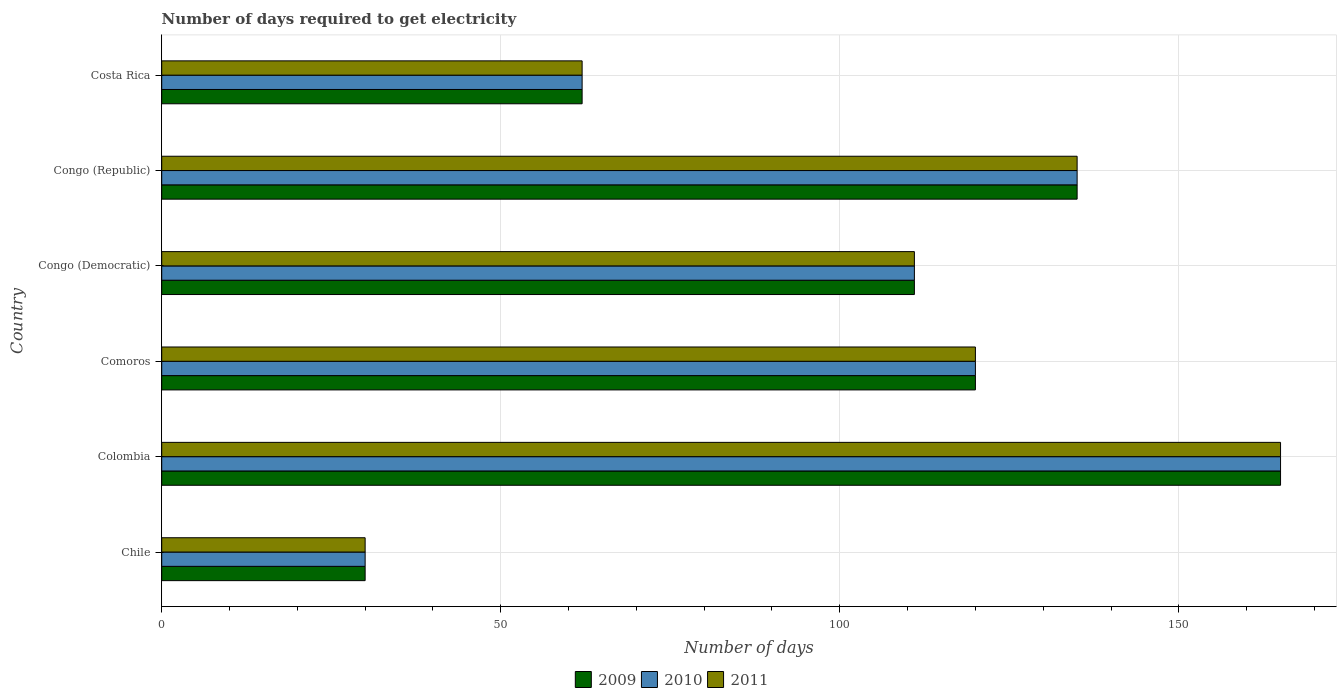How many different coloured bars are there?
Ensure brevity in your answer.  3. Are the number of bars on each tick of the Y-axis equal?
Your answer should be compact. Yes. How many bars are there on the 5th tick from the bottom?
Provide a short and direct response. 3. In how many cases, is the number of bars for a given country not equal to the number of legend labels?
Your answer should be compact. 0. What is the number of days required to get electricity in in 2011 in Costa Rica?
Offer a very short reply. 62. Across all countries, what is the maximum number of days required to get electricity in in 2010?
Your answer should be very brief. 165. In which country was the number of days required to get electricity in in 2010 maximum?
Offer a very short reply. Colombia. What is the total number of days required to get electricity in in 2009 in the graph?
Keep it short and to the point. 623. What is the difference between the number of days required to get electricity in in 2009 in Costa Rica and the number of days required to get electricity in in 2011 in Colombia?
Your answer should be compact. -103. What is the average number of days required to get electricity in in 2009 per country?
Ensure brevity in your answer.  103.83. What is the difference between the number of days required to get electricity in in 2011 and number of days required to get electricity in in 2010 in Colombia?
Your response must be concise. 0. What is the ratio of the number of days required to get electricity in in 2011 in Chile to that in Colombia?
Offer a very short reply. 0.18. Is the number of days required to get electricity in in 2011 in Comoros less than that in Congo (Democratic)?
Your answer should be very brief. No. What is the difference between the highest and the second highest number of days required to get electricity in in 2009?
Your answer should be very brief. 30. What is the difference between the highest and the lowest number of days required to get electricity in in 2009?
Your answer should be very brief. 135. What does the 3rd bar from the top in Colombia represents?
Keep it short and to the point. 2009. What does the 2nd bar from the bottom in Comoros represents?
Offer a very short reply. 2010. Is it the case that in every country, the sum of the number of days required to get electricity in in 2010 and number of days required to get electricity in in 2009 is greater than the number of days required to get electricity in in 2011?
Your response must be concise. Yes. What is the difference between two consecutive major ticks on the X-axis?
Provide a short and direct response. 50. Are the values on the major ticks of X-axis written in scientific E-notation?
Your response must be concise. No. What is the title of the graph?
Ensure brevity in your answer.  Number of days required to get electricity. Does "1995" appear as one of the legend labels in the graph?
Give a very brief answer. No. What is the label or title of the X-axis?
Give a very brief answer. Number of days. What is the Number of days in 2009 in Colombia?
Offer a terse response. 165. What is the Number of days of 2010 in Colombia?
Ensure brevity in your answer.  165. What is the Number of days in 2011 in Colombia?
Your response must be concise. 165. What is the Number of days in 2009 in Comoros?
Ensure brevity in your answer.  120. What is the Number of days of 2010 in Comoros?
Ensure brevity in your answer.  120. What is the Number of days in 2011 in Comoros?
Ensure brevity in your answer.  120. What is the Number of days in 2009 in Congo (Democratic)?
Offer a very short reply. 111. What is the Number of days of 2010 in Congo (Democratic)?
Offer a very short reply. 111. What is the Number of days in 2011 in Congo (Democratic)?
Your answer should be compact. 111. What is the Number of days of 2009 in Congo (Republic)?
Give a very brief answer. 135. What is the Number of days of 2010 in Congo (Republic)?
Your response must be concise. 135. What is the Number of days of 2011 in Congo (Republic)?
Make the answer very short. 135. What is the Number of days in 2010 in Costa Rica?
Provide a succinct answer. 62. Across all countries, what is the maximum Number of days of 2009?
Provide a short and direct response. 165. Across all countries, what is the maximum Number of days of 2010?
Ensure brevity in your answer.  165. Across all countries, what is the maximum Number of days in 2011?
Keep it short and to the point. 165. Across all countries, what is the minimum Number of days of 2009?
Give a very brief answer. 30. Across all countries, what is the minimum Number of days in 2011?
Offer a terse response. 30. What is the total Number of days in 2009 in the graph?
Provide a short and direct response. 623. What is the total Number of days in 2010 in the graph?
Make the answer very short. 623. What is the total Number of days in 2011 in the graph?
Provide a short and direct response. 623. What is the difference between the Number of days in 2009 in Chile and that in Colombia?
Ensure brevity in your answer.  -135. What is the difference between the Number of days of 2010 in Chile and that in Colombia?
Give a very brief answer. -135. What is the difference between the Number of days in 2011 in Chile and that in Colombia?
Offer a very short reply. -135. What is the difference between the Number of days of 2009 in Chile and that in Comoros?
Your response must be concise. -90. What is the difference between the Number of days in 2010 in Chile and that in Comoros?
Give a very brief answer. -90. What is the difference between the Number of days in 2011 in Chile and that in Comoros?
Make the answer very short. -90. What is the difference between the Number of days of 2009 in Chile and that in Congo (Democratic)?
Give a very brief answer. -81. What is the difference between the Number of days of 2010 in Chile and that in Congo (Democratic)?
Provide a succinct answer. -81. What is the difference between the Number of days in 2011 in Chile and that in Congo (Democratic)?
Your answer should be very brief. -81. What is the difference between the Number of days of 2009 in Chile and that in Congo (Republic)?
Provide a short and direct response. -105. What is the difference between the Number of days of 2010 in Chile and that in Congo (Republic)?
Provide a succinct answer. -105. What is the difference between the Number of days of 2011 in Chile and that in Congo (Republic)?
Your answer should be very brief. -105. What is the difference between the Number of days of 2009 in Chile and that in Costa Rica?
Your answer should be very brief. -32. What is the difference between the Number of days in 2010 in Chile and that in Costa Rica?
Provide a succinct answer. -32. What is the difference between the Number of days in 2011 in Chile and that in Costa Rica?
Provide a succinct answer. -32. What is the difference between the Number of days in 2009 in Colombia and that in Comoros?
Offer a terse response. 45. What is the difference between the Number of days in 2009 in Colombia and that in Congo (Democratic)?
Your response must be concise. 54. What is the difference between the Number of days in 2010 in Colombia and that in Congo (Republic)?
Offer a terse response. 30. What is the difference between the Number of days of 2009 in Colombia and that in Costa Rica?
Provide a short and direct response. 103. What is the difference between the Number of days of 2010 in Colombia and that in Costa Rica?
Offer a terse response. 103. What is the difference between the Number of days of 2011 in Colombia and that in Costa Rica?
Offer a terse response. 103. What is the difference between the Number of days of 2009 in Comoros and that in Congo (Democratic)?
Your response must be concise. 9. What is the difference between the Number of days in 2009 in Comoros and that in Congo (Republic)?
Your response must be concise. -15. What is the difference between the Number of days in 2010 in Congo (Democratic) and that in Congo (Republic)?
Provide a succinct answer. -24. What is the difference between the Number of days in 2011 in Congo (Democratic) and that in Congo (Republic)?
Offer a terse response. -24. What is the difference between the Number of days of 2010 in Congo (Democratic) and that in Costa Rica?
Give a very brief answer. 49. What is the difference between the Number of days in 2009 in Congo (Republic) and that in Costa Rica?
Provide a succinct answer. 73. What is the difference between the Number of days of 2009 in Chile and the Number of days of 2010 in Colombia?
Your answer should be very brief. -135. What is the difference between the Number of days of 2009 in Chile and the Number of days of 2011 in Colombia?
Your response must be concise. -135. What is the difference between the Number of days in 2010 in Chile and the Number of days in 2011 in Colombia?
Your response must be concise. -135. What is the difference between the Number of days in 2009 in Chile and the Number of days in 2010 in Comoros?
Your answer should be compact. -90. What is the difference between the Number of days in 2009 in Chile and the Number of days in 2011 in Comoros?
Your answer should be compact. -90. What is the difference between the Number of days in 2010 in Chile and the Number of days in 2011 in Comoros?
Provide a succinct answer. -90. What is the difference between the Number of days of 2009 in Chile and the Number of days of 2010 in Congo (Democratic)?
Ensure brevity in your answer.  -81. What is the difference between the Number of days in 2009 in Chile and the Number of days in 2011 in Congo (Democratic)?
Provide a short and direct response. -81. What is the difference between the Number of days of 2010 in Chile and the Number of days of 2011 in Congo (Democratic)?
Ensure brevity in your answer.  -81. What is the difference between the Number of days of 2009 in Chile and the Number of days of 2010 in Congo (Republic)?
Give a very brief answer. -105. What is the difference between the Number of days in 2009 in Chile and the Number of days in 2011 in Congo (Republic)?
Ensure brevity in your answer.  -105. What is the difference between the Number of days of 2010 in Chile and the Number of days of 2011 in Congo (Republic)?
Your answer should be very brief. -105. What is the difference between the Number of days of 2009 in Chile and the Number of days of 2010 in Costa Rica?
Offer a terse response. -32. What is the difference between the Number of days of 2009 in Chile and the Number of days of 2011 in Costa Rica?
Your answer should be very brief. -32. What is the difference between the Number of days in 2010 in Chile and the Number of days in 2011 in Costa Rica?
Ensure brevity in your answer.  -32. What is the difference between the Number of days of 2009 in Colombia and the Number of days of 2011 in Comoros?
Your answer should be very brief. 45. What is the difference between the Number of days in 2010 in Colombia and the Number of days in 2011 in Comoros?
Provide a short and direct response. 45. What is the difference between the Number of days of 2009 in Colombia and the Number of days of 2011 in Congo (Democratic)?
Keep it short and to the point. 54. What is the difference between the Number of days in 2009 in Colombia and the Number of days in 2010 in Congo (Republic)?
Offer a very short reply. 30. What is the difference between the Number of days in 2009 in Colombia and the Number of days in 2011 in Congo (Republic)?
Offer a terse response. 30. What is the difference between the Number of days in 2009 in Colombia and the Number of days in 2010 in Costa Rica?
Offer a very short reply. 103. What is the difference between the Number of days in 2009 in Colombia and the Number of days in 2011 in Costa Rica?
Keep it short and to the point. 103. What is the difference between the Number of days of 2010 in Colombia and the Number of days of 2011 in Costa Rica?
Give a very brief answer. 103. What is the difference between the Number of days in 2009 in Comoros and the Number of days in 2010 in Congo (Democratic)?
Offer a terse response. 9. What is the difference between the Number of days of 2010 in Comoros and the Number of days of 2011 in Congo (Democratic)?
Provide a succinct answer. 9. What is the difference between the Number of days in 2009 in Comoros and the Number of days in 2010 in Costa Rica?
Provide a short and direct response. 58. What is the difference between the Number of days of 2009 in Comoros and the Number of days of 2011 in Costa Rica?
Your answer should be very brief. 58. What is the difference between the Number of days of 2010 in Congo (Democratic) and the Number of days of 2011 in Congo (Republic)?
Your answer should be very brief. -24. What is the difference between the Number of days of 2009 in Congo (Democratic) and the Number of days of 2010 in Costa Rica?
Make the answer very short. 49. What is the difference between the Number of days of 2009 in Congo (Democratic) and the Number of days of 2011 in Costa Rica?
Offer a terse response. 49. What is the difference between the Number of days of 2010 in Congo (Democratic) and the Number of days of 2011 in Costa Rica?
Offer a very short reply. 49. What is the difference between the Number of days of 2009 in Congo (Republic) and the Number of days of 2010 in Costa Rica?
Ensure brevity in your answer.  73. What is the difference between the Number of days of 2009 in Congo (Republic) and the Number of days of 2011 in Costa Rica?
Your answer should be compact. 73. What is the average Number of days in 2009 per country?
Offer a terse response. 103.83. What is the average Number of days in 2010 per country?
Your response must be concise. 103.83. What is the average Number of days in 2011 per country?
Your response must be concise. 103.83. What is the difference between the Number of days of 2009 and Number of days of 2010 in Chile?
Your answer should be compact. 0. What is the difference between the Number of days in 2009 and Number of days in 2011 in Chile?
Provide a succinct answer. 0. What is the difference between the Number of days in 2010 and Number of days in 2011 in Chile?
Provide a succinct answer. 0. What is the difference between the Number of days of 2009 and Number of days of 2010 in Colombia?
Give a very brief answer. 0. What is the difference between the Number of days in 2009 and Number of days in 2010 in Comoros?
Give a very brief answer. 0. What is the difference between the Number of days of 2010 and Number of days of 2011 in Comoros?
Ensure brevity in your answer.  0. What is the difference between the Number of days of 2009 and Number of days of 2010 in Congo (Democratic)?
Make the answer very short. 0. What is the difference between the Number of days of 2009 and Number of days of 2011 in Congo (Democratic)?
Offer a terse response. 0. What is the difference between the Number of days of 2009 and Number of days of 2010 in Congo (Republic)?
Offer a very short reply. 0. What is the difference between the Number of days of 2009 and Number of days of 2011 in Congo (Republic)?
Keep it short and to the point. 0. What is the difference between the Number of days of 2010 and Number of days of 2011 in Congo (Republic)?
Provide a succinct answer. 0. What is the difference between the Number of days of 2009 and Number of days of 2011 in Costa Rica?
Keep it short and to the point. 0. What is the ratio of the Number of days in 2009 in Chile to that in Colombia?
Offer a terse response. 0.18. What is the ratio of the Number of days in 2010 in Chile to that in Colombia?
Offer a terse response. 0.18. What is the ratio of the Number of days of 2011 in Chile to that in Colombia?
Offer a very short reply. 0.18. What is the ratio of the Number of days of 2010 in Chile to that in Comoros?
Your answer should be compact. 0.25. What is the ratio of the Number of days of 2011 in Chile to that in Comoros?
Make the answer very short. 0.25. What is the ratio of the Number of days in 2009 in Chile to that in Congo (Democratic)?
Ensure brevity in your answer.  0.27. What is the ratio of the Number of days of 2010 in Chile to that in Congo (Democratic)?
Provide a short and direct response. 0.27. What is the ratio of the Number of days of 2011 in Chile to that in Congo (Democratic)?
Keep it short and to the point. 0.27. What is the ratio of the Number of days of 2009 in Chile to that in Congo (Republic)?
Ensure brevity in your answer.  0.22. What is the ratio of the Number of days of 2010 in Chile to that in Congo (Republic)?
Make the answer very short. 0.22. What is the ratio of the Number of days of 2011 in Chile to that in Congo (Republic)?
Offer a terse response. 0.22. What is the ratio of the Number of days in 2009 in Chile to that in Costa Rica?
Offer a very short reply. 0.48. What is the ratio of the Number of days in 2010 in Chile to that in Costa Rica?
Ensure brevity in your answer.  0.48. What is the ratio of the Number of days of 2011 in Chile to that in Costa Rica?
Your answer should be very brief. 0.48. What is the ratio of the Number of days of 2009 in Colombia to that in Comoros?
Your answer should be very brief. 1.38. What is the ratio of the Number of days in 2010 in Colombia to that in Comoros?
Provide a succinct answer. 1.38. What is the ratio of the Number of days in 2011 in Colombia to that in Comoros?
Your response must be concise. 1.38. What is the ratio of the Number of days in 2009 in Colombia to that in Congo (Democratic)?
Keep it short and to the point. 1.49. What is the ratio of the Number of days of 2010 in Colombia to that in Congo (Democratic)?
Provide a short and direct response. 1.49. What is the ratio of the Number of days of 2011 in Colombia to that in Congo (Democratic)?
Your answer should be very brief. 1.49. What is the ratio of the Number of days in 2009 in Colombia to that in Congo (Republic)?
Your answer should be compact. 1.22. What is the ratio of the Number of days in 2010 in Colombia to that in Congo (Republic)?
Give a very brief answer. 1.22. What is the ratio of the Number of days of 2011 in Colombia to that in Congo (Republic)?
Offer a terse response. 1.22. What is the ratio of the Number of days of 2009 in Colombia to that in Costa Rica?
Make the answer very short. 2.66. What is the ratio of the Number of days of 2010 in Colombia to that in Costa Rica?
Your answer should be compact. 2.66. What is the ratio of the Number of days in 2011 in Colombia to that in Costa Rica?
Your response must be concise. 2.66. What is the ratio of the Number of days in 2009 in Comoros to that in Congo (Democratic)?
Give a very brief answer. 1.08. What is the ratio of the Number of days of 2010 in Comoros to that in Congo (Democratic)?
Your answer should be very brief. 1.08. What is the ratio of the Number of days in 2011 in Comoros to that in Congo (Democratic)?
Make the answer very short. 1.08. What is the ratio of the Number of days in 2009 in Comoros to that in Congo (Republic)?
Make the answer very short. 0.89. What is the ratio of the Number of days in 2010 in Comoros to that in Congo (Republic)?
Your answer should be very brief. 0.89. What is the ratio of the Number of days in 2011 in Comoros to that in Congo (Republic)?
Provide a succinct answer. 0.89. What is the ratio of the Number of days of 2009 in Comoros to that in Costa Rica?
Keep it short and to the point. 1.94. What is the ratio of the Number of days of 2010 in Comoros to that in Costa Rica?
Offer a terse response. 1.94. What is the ratio of the Number of days in 2011 in Comoros to that in Costa Rica?
Keep it short and to the point. 1.94. What is the ratio of the Number of days of 2009 in Congo (Democratic) to that in Congo (Republic)?
Give a very brief answer. 0.82. What is the ratio of the Number of days in 2010 in Congo (Democratic) to that in Congo (Republic)?
Give a very brief answer. 0.82. What is the ratio of the Number of days of 2011 in Congo (Democratic) to that in Congo (Republic)?
Your answer should be very brief. 0.82. What is the ratio of the Number of days in 2009 in Congo (Democratic) to that in Costa Rica?
Offer a terse response. 1.79. What is the ratio of the Number of days of 2010 in Congo (Democratic) to that in Costa Rica?
Give a very brief answer. 1.79. What is the ratio of the Number of days of 2011 in Congo (Democratic) to that in Costa Rica?
Provide a succinct answer. 1.79. What is the ratio of the Number of days of 2009 in Congo (Republic) to that in Costa Rica?
Offer a terse response. 2.18. What is the ratio of the Number of days of 2010 in Congo (Republic) to that in Costa Rica?
Offer a terse response. 2.18. What is the ratio of the Number of days in 2011 in Congo (Republic) to that in Costa Rica?
Ensure brevity in your answer.  2.18. What is the difference between the highest and the second highest Number of days in 2011?
Keep it short and to the point. 30. What is the difference between the highest and the lowest Number of days of 2009?
Offer a very short reply. 135. What is the difference between the highest and the lowest Number of days in 2010?
Provide a succinct answer. 135. What is the difference between the highest and the lowest Number of days in 2011?
Give a very brief answer. 135. 